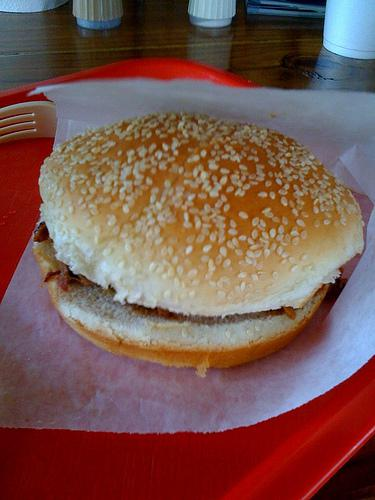Question: what color is the paper?
Choices:
A. White.
B. Red.
C. Yellow.
D. Tan.
Answer with the letter. Answer: A Question: where is the tray?
Choices:
A. In the sink.
B. On the table.
C. On the counter.
D. In the cabinet.
Answer with the letter. Answer: B Question: how many burgers are there?
Choices:
A. One.
B. Two.
C. Three.
D. Four.
Answer with the letter. Answer: A Question: where is the burger?
Choices:
A. On the plate.
B. On the grill.
C. In the bag.
D. On the paper.
Answer with the letter. Answer: D 